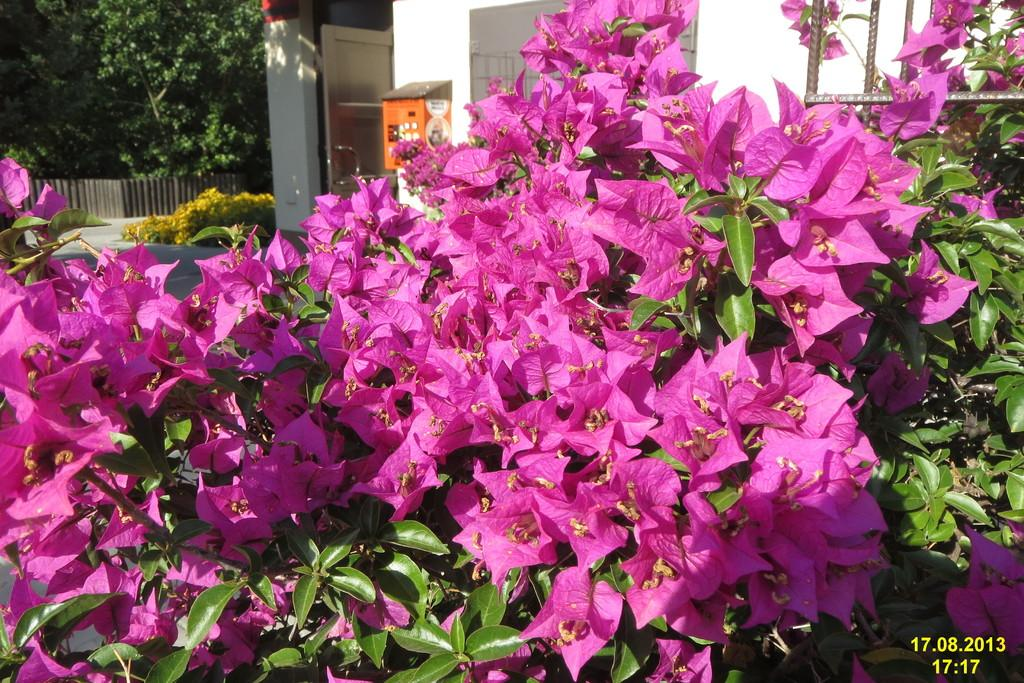What type of plant is visible in the image? There is a plant with flowers in the image. What structure can be seen at the top of the image? There is a building at the top of the image. Where is the tree located in the image? There is a tree in the top left of the image. What type of light is shining on the beef in the image? There is no beef present in the image, and therefore no light shining on it. 